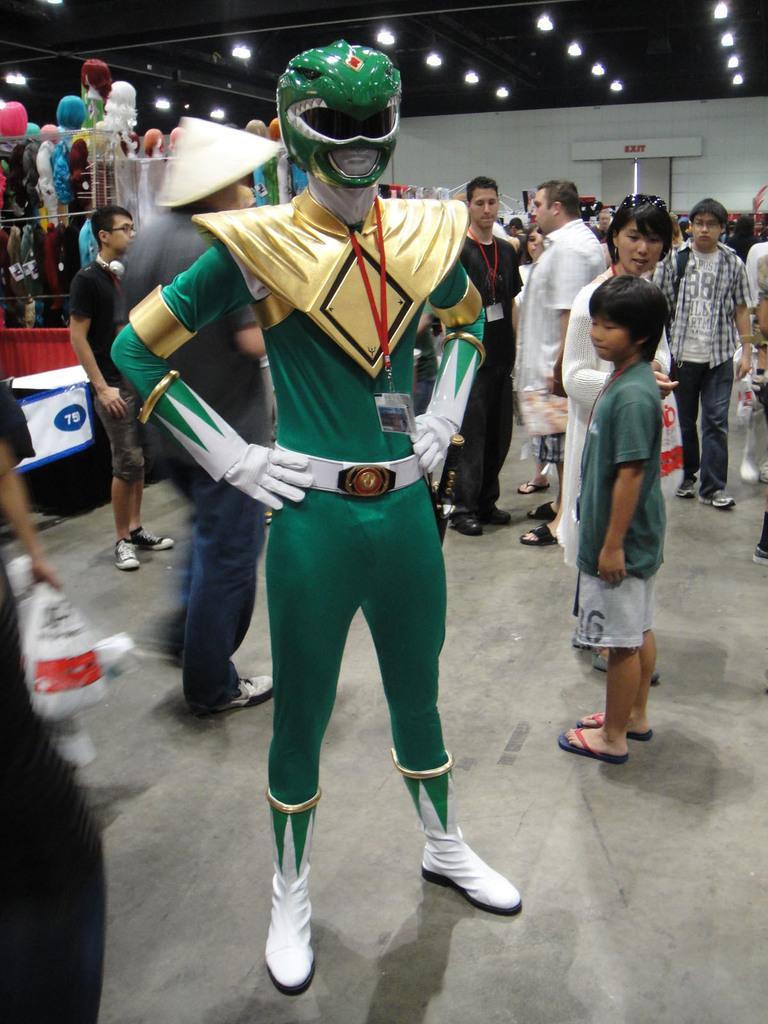In one or two sentences, can you explain what this image depicts? In the image we can see there is a person wearing green colour dress and green colour helmet. Behind there are other people standing and the people are wearing id cards in their neck. 